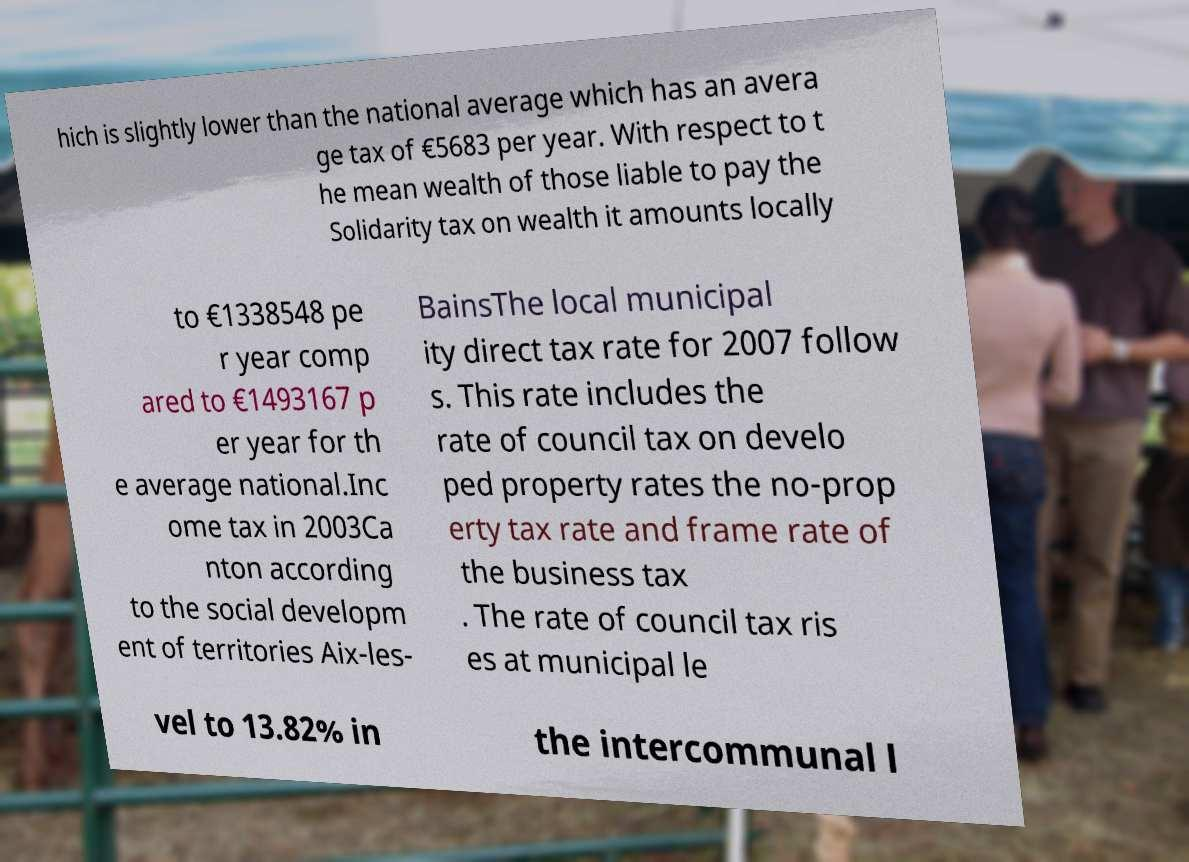Can you read and provide the text displayed in the image?This photo seems to have some interesting text. Can you extract and type it out for me? hich is slightly lower than the national average which has an avera ge tax of €5683 per year. With respect to t he mean wealth of those liable to pay the Solidarity tax on wealth it amounts locally to €1338548 pe r year comp ared to €1493167 p er year for th e average national.Inc ome tax in 2003Ca nton according to the social developm ent of territories Aix-les- BainsThe local municipal ity direct tax rate for 2007 follow s. This rate includes the rate of council tax on develo ped property rates the no-prop erty tax rate and frame rate of the business tax . The rate of council tax ris es at municipal le vel to 13.82% in the intercommunal l 